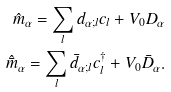<formula> <loc_0><loc_0><loc_500><loc_500>\hat { m } _ { \alpha } = \sum _ { l } d _ { \alpha ; l } c _ { l } + V _ { 0 } D _ { \alpha } \\ \hat { \bar { m } } _ { \alpha } = \sum _ { l } \bar { d } _ { \alpha ; l } c ^ { \dag } _ { l } + V _ { 0 } \bar { D } _ { \alpha } .</formula> 